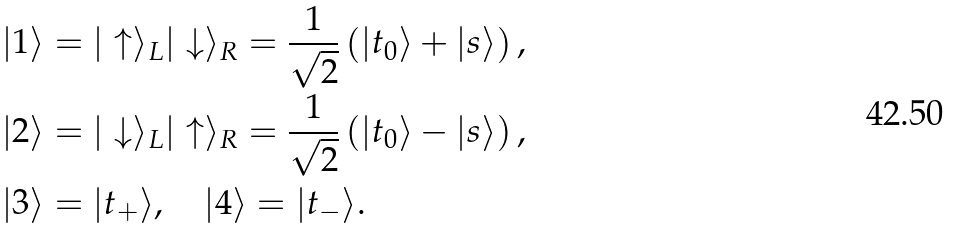<formula> <loc_0><loc_0><loc_500><loc_500>| 1 \rangle & = | \uparrow \rangle _ { L } | \downarrow \rangle _ { R } = \frac { 1 } { \sqrt { 2 } } \left ( | t _ { 0 } \rangle + | s \rangle \right ) , \\ | 2 \rangle & = | \downarrow \rangle _ { L } | \uparrow \rangle _ { R } = \frac { 1 } { \sqrt { 2 } } \left ( | t _ { 0 } \rangle - | s \rangle \right ) , \\ | 3 \rangle & = | t _ { + } \rangle , \quad | 4 \rangle = | t _ { - } \rangle .</formula> 